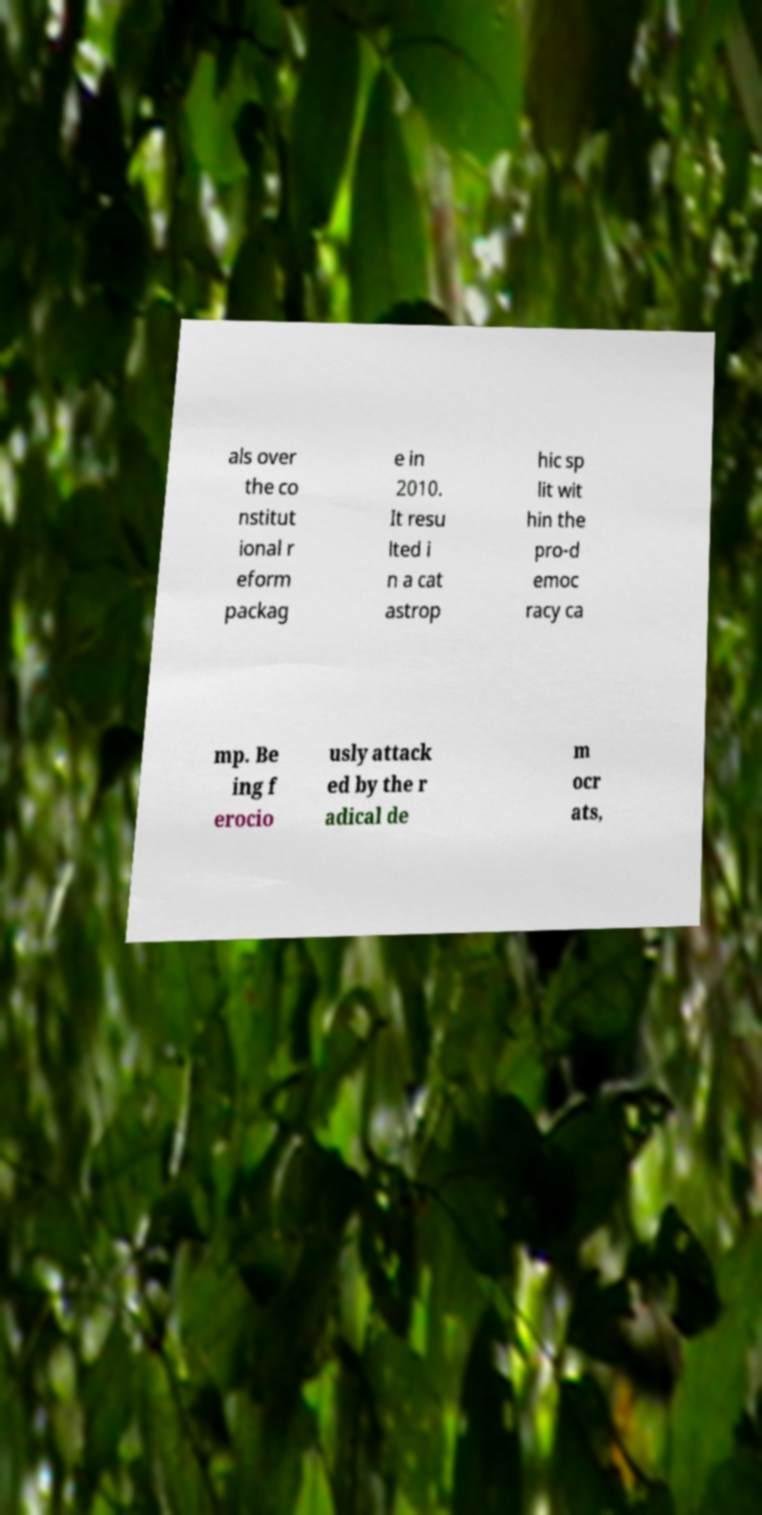Can you accurately transcribe the text from the provided image for me? als over the co nstitut ional r eform packag e in 2010. It resu lted i n a cat astrop hic sp lit wit hin the pro-d emoc racy ca mp. Be ing f erocio usly attack ed by the r adical de m ocr ats, 